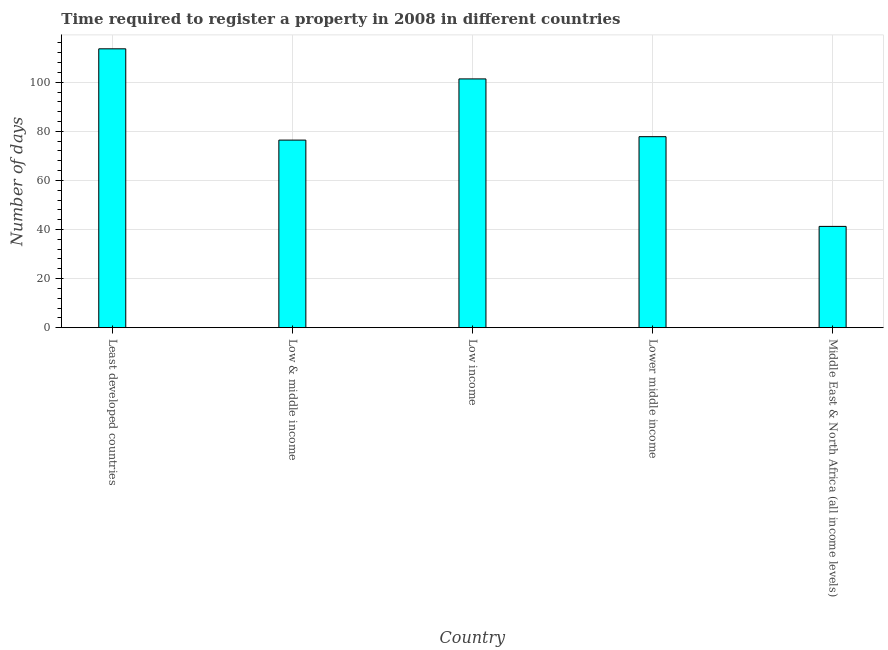Does the graph contain any zero values?
Make the answer very short. No. What is the title of the graph?
Provide a succinct answer. Time required to register a property in 2008 in different countries. What is the label or title of the Y-axis?
Make the answer very short. Number of days. What is the number of days required to register property in Low income?
Provide a succinct answer. 101.36. Across all countries, what is the maximum number of days required to register property?
Your response must be concise. 113.62. Across all countries, what is the minimum number of days required to register property?
Your answer should be compact. 41.26. In which country was the number of days required to register property maximum?
Provide a succinct answer. Least developed countries. In which country was the number of days required to register property minimum?
Your response must be concise. Middle East & North Africa (all income levels). What is the sum of the number of days required to register property?
Provide a short and direct response. 410.49. What is the difference between the number of days required to register property in Low & middle income and Lower middle income?
Make the answer very short. -1.4. What is the average number of days required to register property per country?
Make the answer very short. 82.1. What is the median number of days required to register property?
Provide a succinct answer. 77.82. What is the ratio of the number of days required to register property in Least developed countries to that in Lower middle income?
Ensure brevity in your answer.  1.46. Is the number of days required to register property in Lower middle income less than that in Middle East & North Africa (all income levels)?
Your answer should be compact. No. Is the difference between the number of days required to register property in Least developed countries and Lower middle income greater than the difference between any two countries?
Ensure brevity in your answer.  No. What is the difference between the highest and the second highest number of days required to register property?
Keep it short and to the point. 12.26. What is the difference between the highest and the lowest number of days required to register property?
Your answer should be very brief. 72.36. In how many countries, is the number of days required to register property greater than the average number of days required to register property taken over all countries?
Offer a very short reply. 2. Are the values on the major ticks of Y-axis written in scientific E-notation?
Offer a terse response. No. What is the Number of days in Least developed countries?
Make the answer very short. 113.62. What is the Number of days in Low & middle income?
Provide a succinct answer. 76.42. What is the Number of days in Low income?
Your response must be concise. 101.36. What is the Number of days of Lower middle income?
Make the answer very short. 77.82. What is the Number of days in Middle East & North Africa (all income levels)?
Provide a succinct answer. 41.26. What is the difference between the Number of days in Least developed countries and Low & middle income?
Offer a very short reply. 37.19. What is the difference between the Number of days in Least developed countries and Low income?
Make the answer very short. 12.26. What is the difference between the Number of days in Least developed countries and Lower middle income?
Your response must be concise. 35.8. What is the difference between the Number of days in Least developed countries and Middle East & North Africa (all income levels)?
Offer a terse response. 72.36. What is the difference between the Number of days in Low & middle income and Low income?
Your response must be concise. -24.93. What is the difference between the Number of days in Low & middle income and Lower middle income?
Provide a short and direct response. -1.4. What is the difference between the Number of days in Low & middle income and Middle East & North Africa (all income levels)?
Offer a very short reply. 35.16. What is the difference between the Number of days in Low income and Lower middle income?
Offer a terse response. 23.54. What is the difference between the Number of days in Low income and Middle East & North Africa (all income levels)?
Provide a short and direct response. 60.09. What is the difference between the Number of days in Lower middle income and Middle East & North Africa (all income levels)?
Offer a terse response. 36.56. What is the ratio of the Number of days in Least developed countries to that in Low & middle income?
Ensure brevity in your answer.  1.49. What is the ratio of the Number of days in Least developed countries to that in Low income?
Your response must be concise. 1.12. What is the ratio of the Number of days in Least developed countries to that in Lower middle income?
Your response must be concise. 1.46. What is the ratio of the Number of days in Least developed countries to that in Middle East & North Africa (all income levels)?
Offer a terse response. 2.75. What is the ratio of the Number of days in Low & middle income to that in Low income?
Provide a short and direct response. 0.75. What is the ratio of the Number of days in Low & middle income to that in Middle East & North Africa (all income levels)?
Give a very brief answer. 1.85. What is the ratio of the Number of days in Low income to that in Lower middle income?
Give a very brief answer. 1.3. What is the ratio of the Number of days in Low income to that in Middle East & North Africa (all income levels)?
Provide a succinct answer. 2.46. What is the ratio of the Number of days in Lower middle income to that in Middle East & North Africa (all income levels)?
Keep it short and to the point. 1.89. 